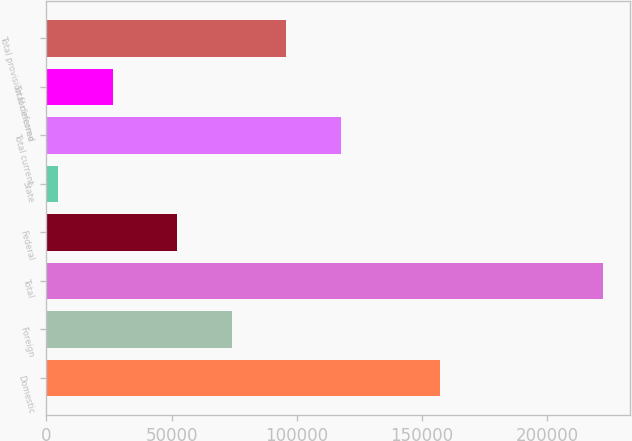<chart> <loc_0><loc_0><loc_500><loc_500><bar_chart><fcel>Domestic<fcel>Foreign<fcel>Total<fcel>Federal<fcel>State<fcel>Total current<fcel>Total deferred<fcel>Total provision for income<nl><fcel>157027<fcel>74023.3<fcel>222126<fcel>52290<fcel>4793<fcel>117490<fcel>26526.3<fcel>95756.6<nl></chart> 